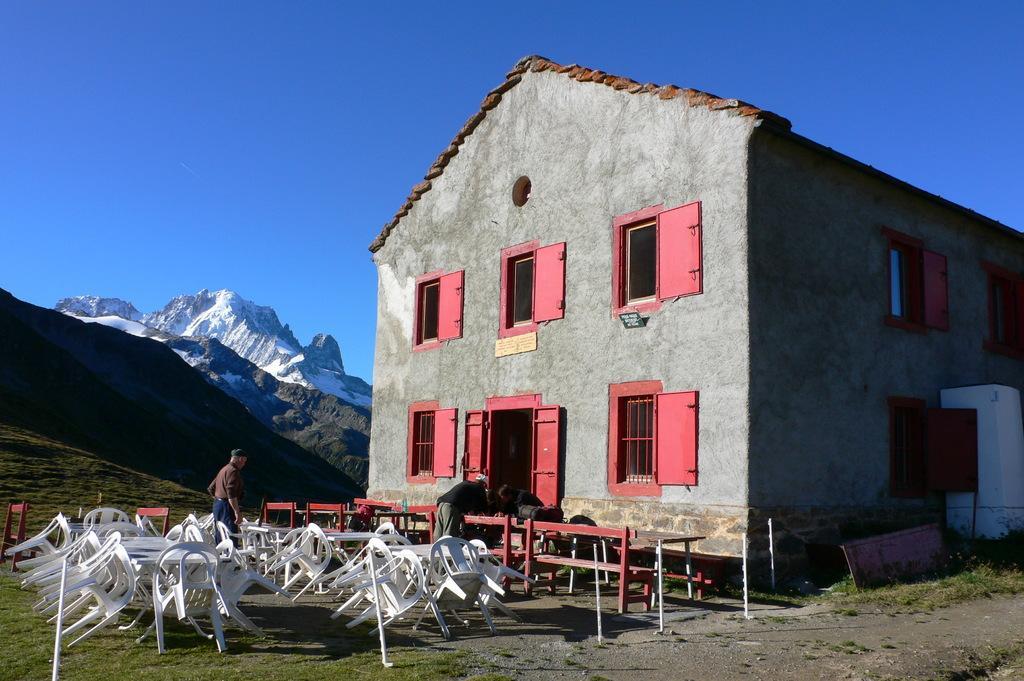Please provide a concise description of this image. In this image in the center there is one house, and on the left side there are some chairs. And in the center there are some benches and some people, at the bottom there is grass. And in the background there are mountains, and at the top there is sky and on the right side of the image there are some boards. 